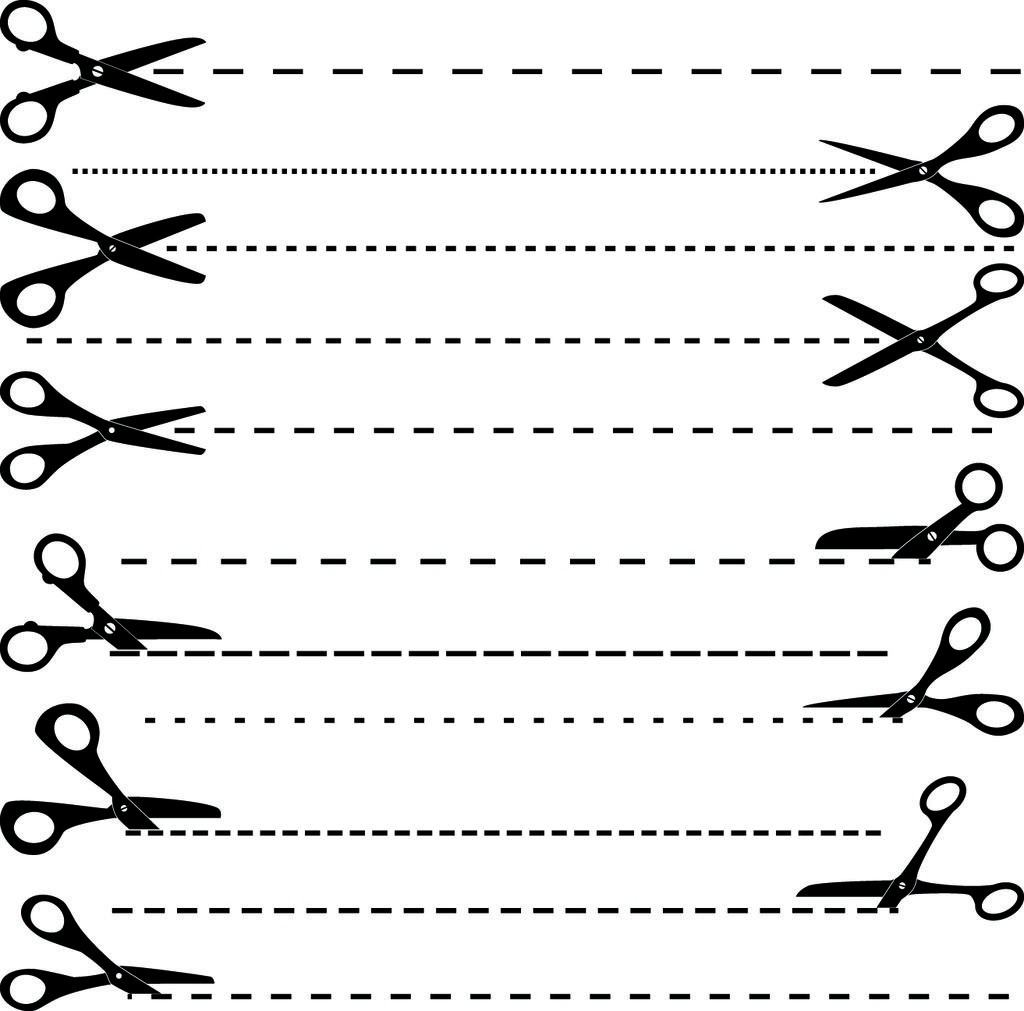What is the color scheme of the image? The image is black and white. What object is depicted in the image? There is an image of scissors in the picture. What type of lines are present in the image? There are dotted lines in the picture. Can you tell me how many people are swimming in the image? There is no swimming or people present in the image; it features an image of scissors and dotted lines. What type of curve is visible in the image? There is no curve visible in the image; it only features an image of scissors and dotted lines. 